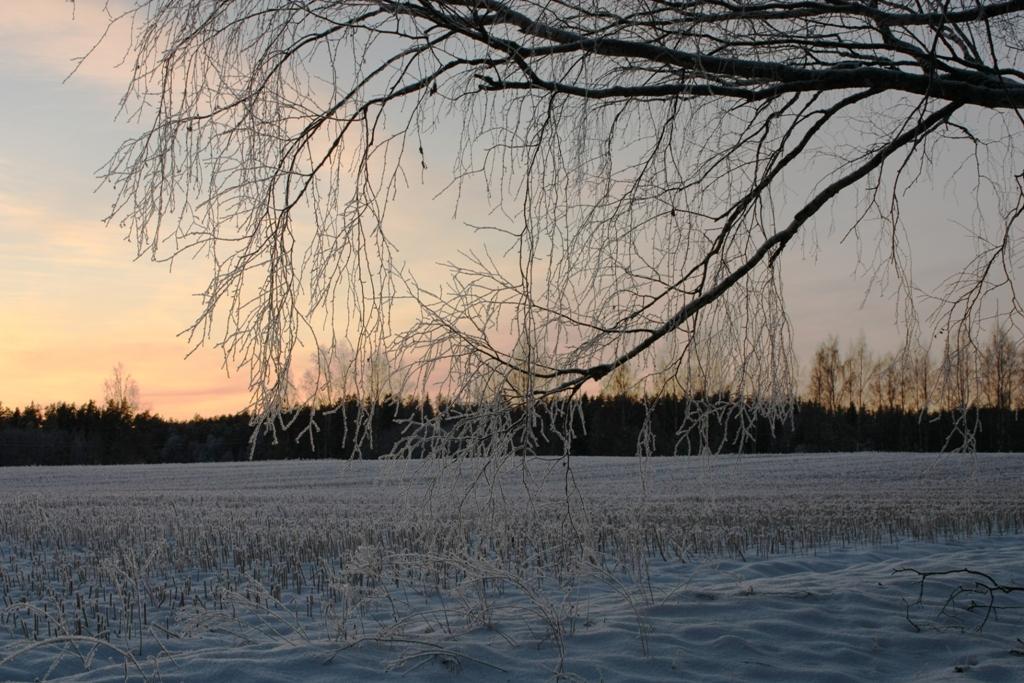In one or two sentences, can you explain what this image depicts? In this image I can see grass and a tree in the front. In the background I can see number of trees, clouds and the sky. 